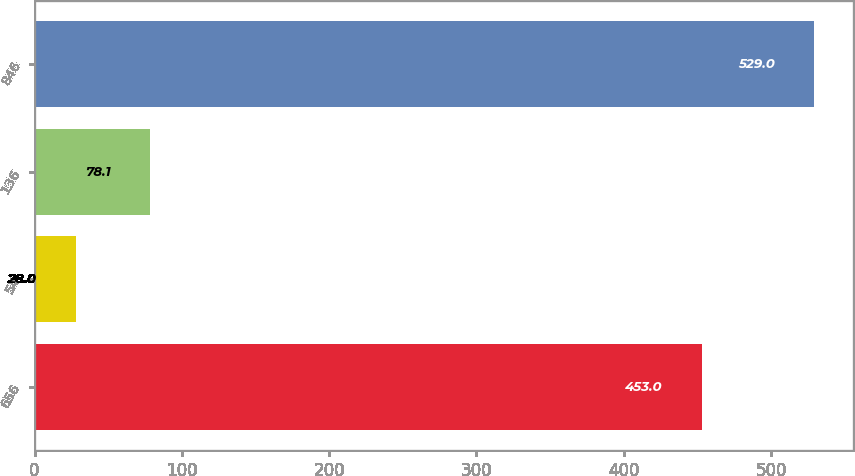Convert chart. <chart><loc_0><loc_0><loc_500><loc_500><bar_chart><fcel>656<fcel>54<fcel>136<fcel>846<nl><fcel>453<fcel>28<fcel>78.1<fcel>529<nl></chart> 